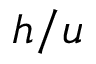Convert formula to latex. <formula><loc_0><loc_0><loc_500><loc_500>h / u</formula> 